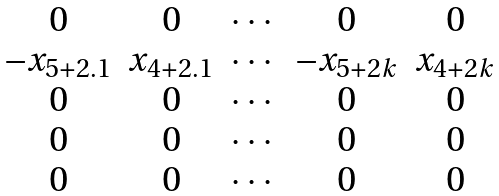Convert formula to latex. <formula><loc_0><loc_0><loc_500><loc_500>\begin{matrix} 0 & 0 & \cdots & 0 & 0 \\ - x _ { 5 + 2 . 1 } & x _ { 4 + 2 . 1 } & \cdots & - x _ { 5 + 2 k } & x _ { 4 + 2 k } \\ 0 & 0 & \cdots & 0 & 0 \\ 0 & 0 & \cdots & 0 & 0 \\ 0 & 0 & \cdots & 0 & 0 \end{matrix}</formula> 